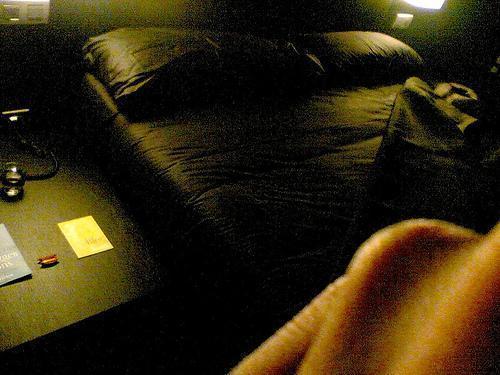How many pillows are on the bed?
Give a very brief answer. 2. How many people are holding children?
Give a very brief answer. 0. 